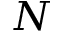<formula> <loc_0><loc_0><loc_500><loc_500>N</formula> 